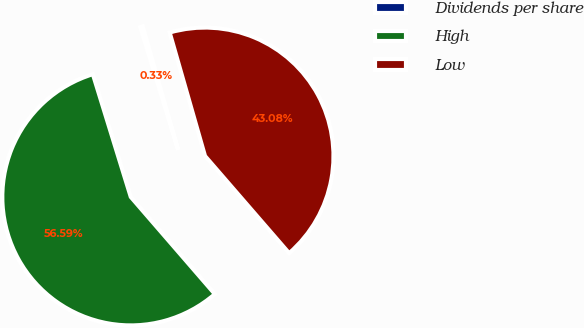<chart> <loc_0><loc_0><loc_500><loc_500><pie_chart><fcel>Dividends per share<fcel>High<fcel>Low<nl><fcel>0.33%<fcel>56.59%<fcel>43.08%<nl></chart> 